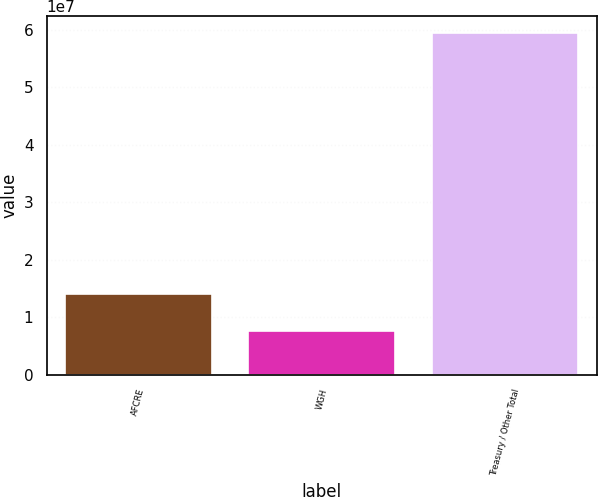Convert chart to OTSL. <chart><loc_0><loc_0><loc_500><loc_500><bar_chart><fcel>AFCRE<fcel>WGH<fcel>Treasury / Other Total<nl><fcel>1.41038e+07<fcel>7.59027e+06<fcel>5.94763e+07<nl></chart> 